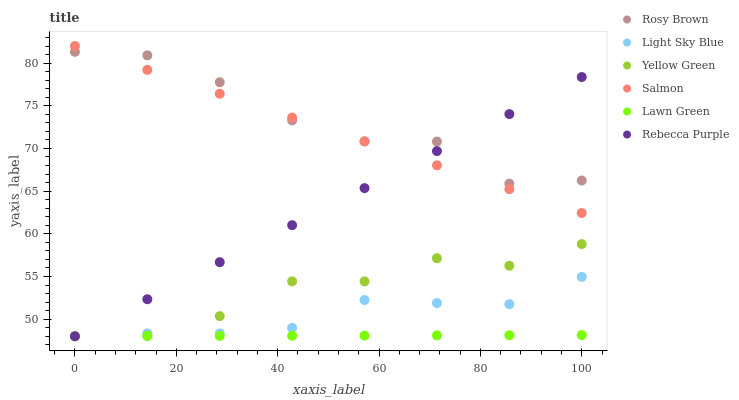Does Lawn Green have the minimum area under the curve?
Answer yes or no. Yes. Does Rosy Brown have the maximum area under the curve?
Answer yes or no. Yes. Does Yellow Green have the minimum area under the curve?
Answer yes or no. No. Does Yellow Green have the maximum area under the curve?
Answer yes or no. No. Is Salmon the smoothest?
Answer yes or no. Yes. Is Rosy Brown the roughest?
Answer yes or no. Yes. Is Yellow Green the smoothest?
Answer yes or no. No. Is Yellow Green the roughest?
Answer yes or no. No. Does Lawn Green have the lowest value?
Answer yes or no. Yes. Does Rosy Brown have the lowest value?
Answer yes or no. No. Does Salmon have the highest value?
Answer yes or no. Yes. Does Yellow Green have the highest value?
Answer yes or no. No. Is Yellow Green less than Salmon?
Answer yes or no. Yes. Is Salmon greater than Lawn Green?
Answer yes or no. Yes. Does Rebecca Purple intersect Salmon?
Answer yes or no. Yes. Is Rebecca Purple less than Salmon?
Answer yes or no. No. Is Rebecca Purple greater than Salmon?
Answer yes or no. No. Does Yellow Green intersect Salmon?
Answer yes or no. No. 